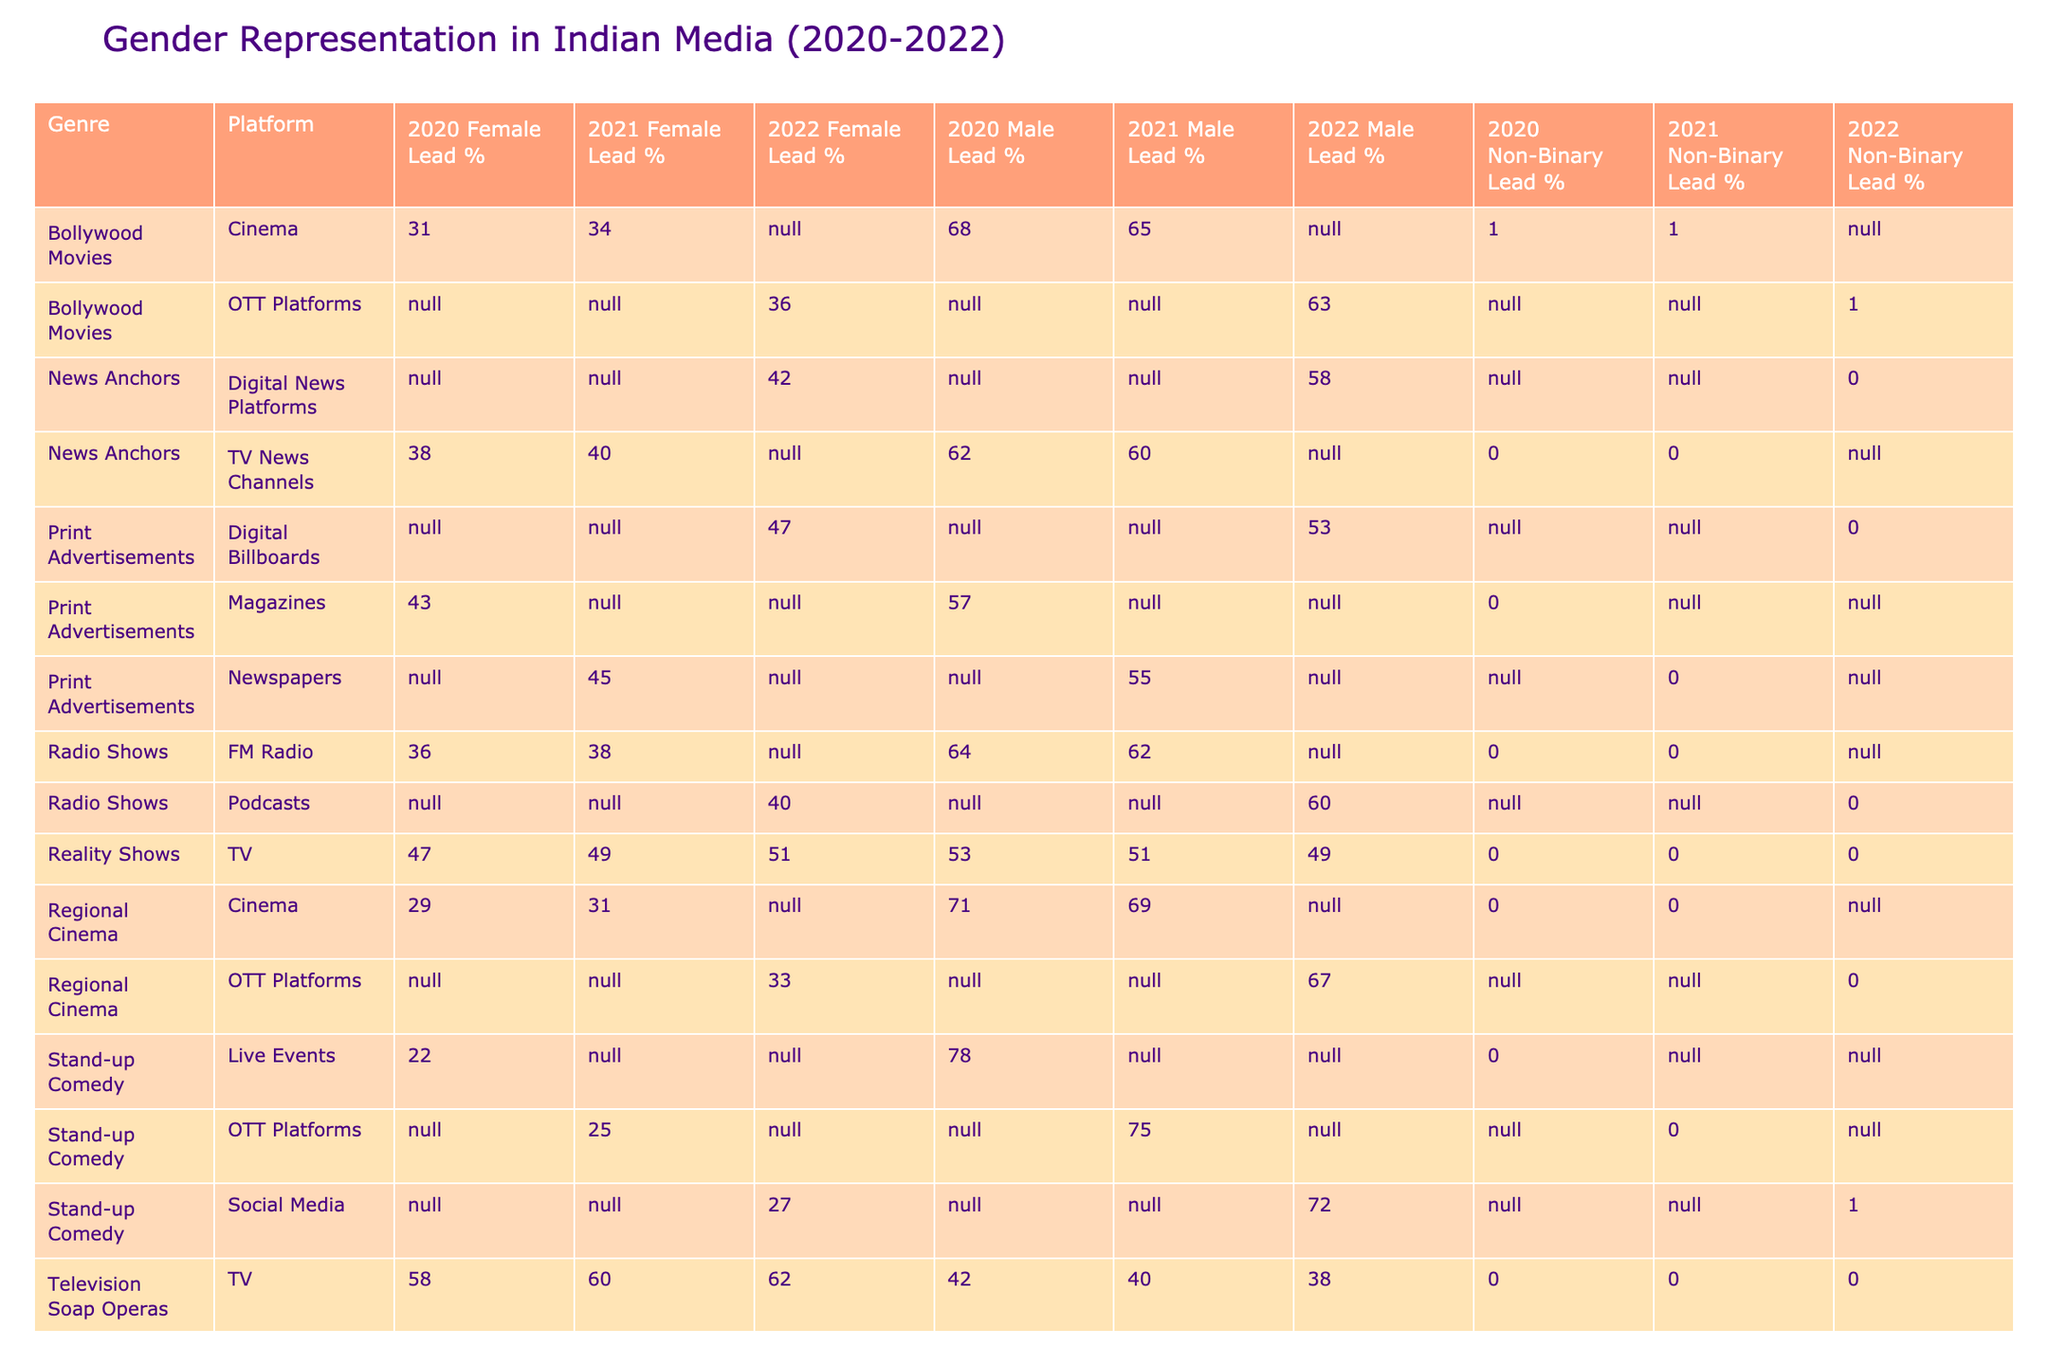What was the Female Lead % in Television Soap Operas in 2021? From the table, we can find the row where Genre is 'Television Soap Operas' and the Year is 2021. The corresponding Female Lead % in that row is 60.
Answer: 60 What is the average Male Lead % across all genres in 2022? To calculate the average, we first identify the Male Lead % values for 2022: 63 (Bollywood Movies), 38 (Television Soap Operas), 50 (Web Series), 58 (News Anchors), 49 (Reality Shows), 67 (Regional Cinema), 55 (YouTube Creators), 53 (Print Advertisements), 60 (Radio Shows), and 72 (Stand-up Comedy). Adding these values gives us 63 + 38 + 50 + 58 + 49 + 67 + 55 + 53 + 60 + 72 =  515. There are 10 entries, so the average is 515/10 = 51.5.
Answer: 51.5 Is there a genre where the Non-Binary Lead % is greater than 1% in any year? Looking through the table, only the Web Series in 2020, 2021, and 2022 contain Non-Binary Lead % values. The values are 2%, 2%, and 2% respectively. Therefore, there is a genre that has Non-Binary Lead % greater than 1%.
Answer: Yes Which genre had the highest Male Lead % in 2020? From the entries for 2020, we can compare the Male Lead % values: 68 (Bollywood Movies), 42 (Television Soap Operas), 55 (Web Series), 62 (News Anchors), 53 (Reality Shows), 71 (Regional Cinema), 59 (YouTube Creators), and 64 (Radio Shows). The highest value is for 'Regional Cinema' with 71.
Answer: 71 In which year and genre did Television Soap Operas have the highest Female Lead %? The Female Lead % for Television Soap Operas is 58% in 2020 and 60% in 2021, but in 2022, it rose further to 62%. The maximum is therefore 62% in 2022.
Answer: 62% in 2022 